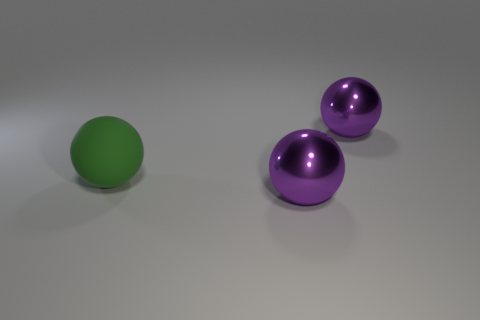Add 1 metallic objects. How many objects exist? 4 Subtract all large green rubber spheres. How many spheres are left? 2 Subtract all purple spheres. How many spheres are left? 1 Subtract all gray balls. Subtract all red cylinders. How many balls are left? 3 Subtract all gray cylinders. How many green balls are left? 1 Subtract all large green rubber balls. Subtract all brown metal objects. How many objects are left? 2 Add 3 balls. How many balls are left? 6 Add 1 big purple balls. How many big purple balls exist? 3 Subtract 0 blue cylinders. How many objects are left? 3 